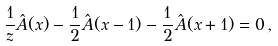Convert formula to latex. <formula><loc_0><loc_0><loc_500><loc_500>\frac { 1 } { z } \hat { A } ( x ) - \frac { 1 } { 2 } \hat { A } ( x - 1 ) - \frac { 1 } { 2 } \hat { A } ( x + 1 ) = 0 \, ,</formula> 